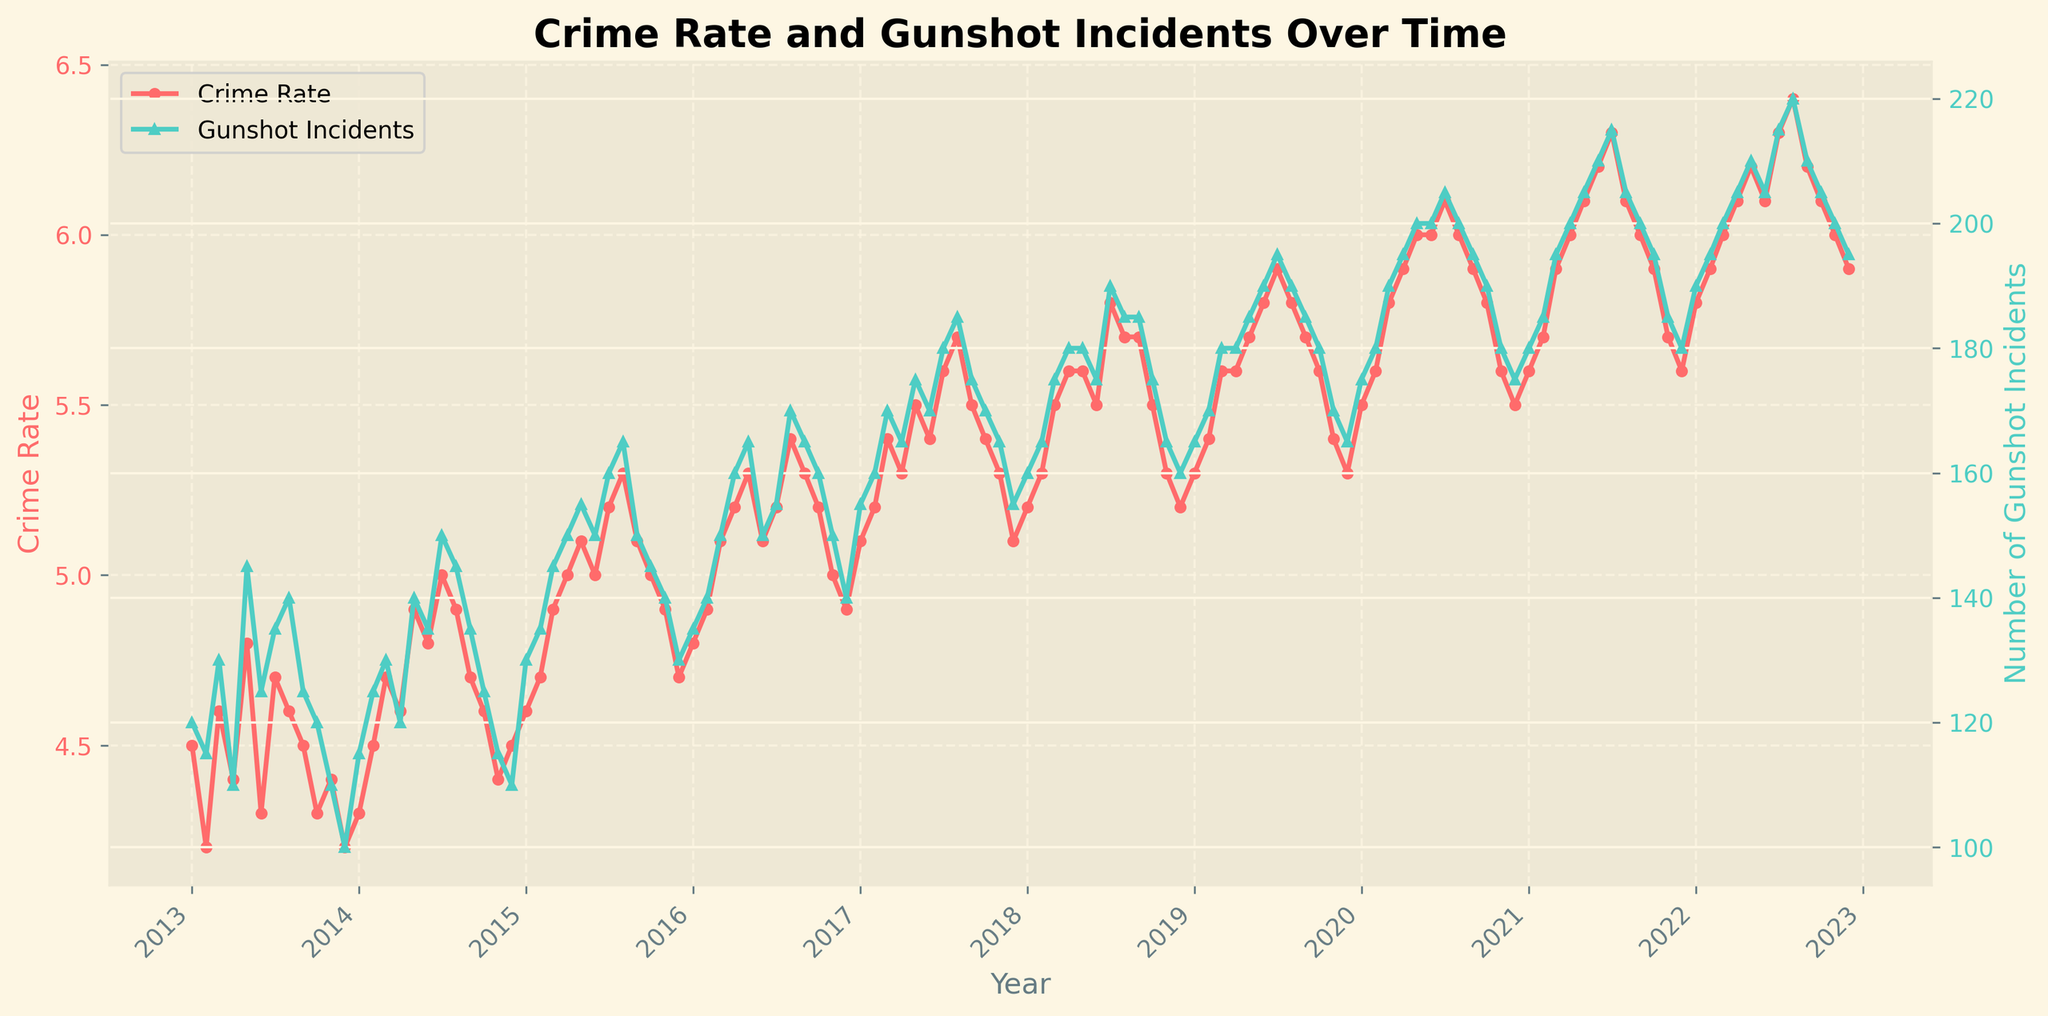What is the title of the figure? The title is usually located at the top of the figure. Here, it reads "Crime Rate and Gunshot Incidents Over Time".
Answer: Crime Rate and Gunshot Incidents Over Time What are the colors used for the Crime Rate and Number of Gunshot Incidents lines? In the figure, the Crime Rate line is represented in red and the Number of Gunshot Incidents line is represented in teal. These colors help to distinguish the two variables.
Answer: Red and Teal How many data points are there for each line in the figure? We can count the number of monthly data points for each year from 2013 to 2022. Each year has 12 months, so multiplying by the 10 years gives us 120 data points.
Answer: 120 What was the highest recorded Crime Rate and when did it occur? The highest point on the Crime Rate line can be observed around the middle of 2022, with a value of 6.4 which occurs in August 2022.
Answer: 6.4 in August 2022 Compare the Number of Gunshot Incidents in January 2013 and January 2022. By locating January 2013 and January 2022 on the x-axis and checking the y-values on the Number of Gunshot Incidents line, we find the values 120 and 190 respectively, indicating an increase.
Answer: Increased from 120 to 190 What is the average Crime Rate for the year 2021? To find the average Crime Rate for 2021, we sum the monthly values: (5.6 + 5.7 + 5.9 + 6.0 + 6.1 + 6.2 + 6.3 + 6.1 + 6.0 + 5.9 + 5.7 + 5.6) = 70.1 and divide by 12, giving us approximately 5.84.
Answer: Approximately 5.84 Did the Number of Gunshot Incidents generally increase, decrease, or stay the same over the decade? Observing the trend of the Gunshot Incidents line from left to right (2013 to 2022), it consistently increases with minor fluctuations, indicating a general upward trend.
Answer: Increased In which year did both the Crime Rate and Number of Gunshot Incidents peak and what were their values? The peak for both variables occurred around the middle of 2022. The Crime Rate peaked at 6.4 in August 2022 and the Number of Gunshot Incidents peaked at 220 in the same month.
Answer: 2022, Crime Rate: 6.4, Gunshot Incidents: 220 What was the trend of Crime Rate from 2020 to 2022? From 2020 to 2022, the Crime Rate shows an increasing trend. Starting from around 5.5 in January 2020, it increases gradually and reaches 6.4 in August 2022.
Answer: Increasing How does the Crime Rate in December 2013 compare to December 2022? By locating December 2013 and December 2022 on the plot, we see the values are around 4.2 and 5.9 respectively, showing that the Crime Rate increased over this period.
Answer: Increased from 4.2 to 5.9 